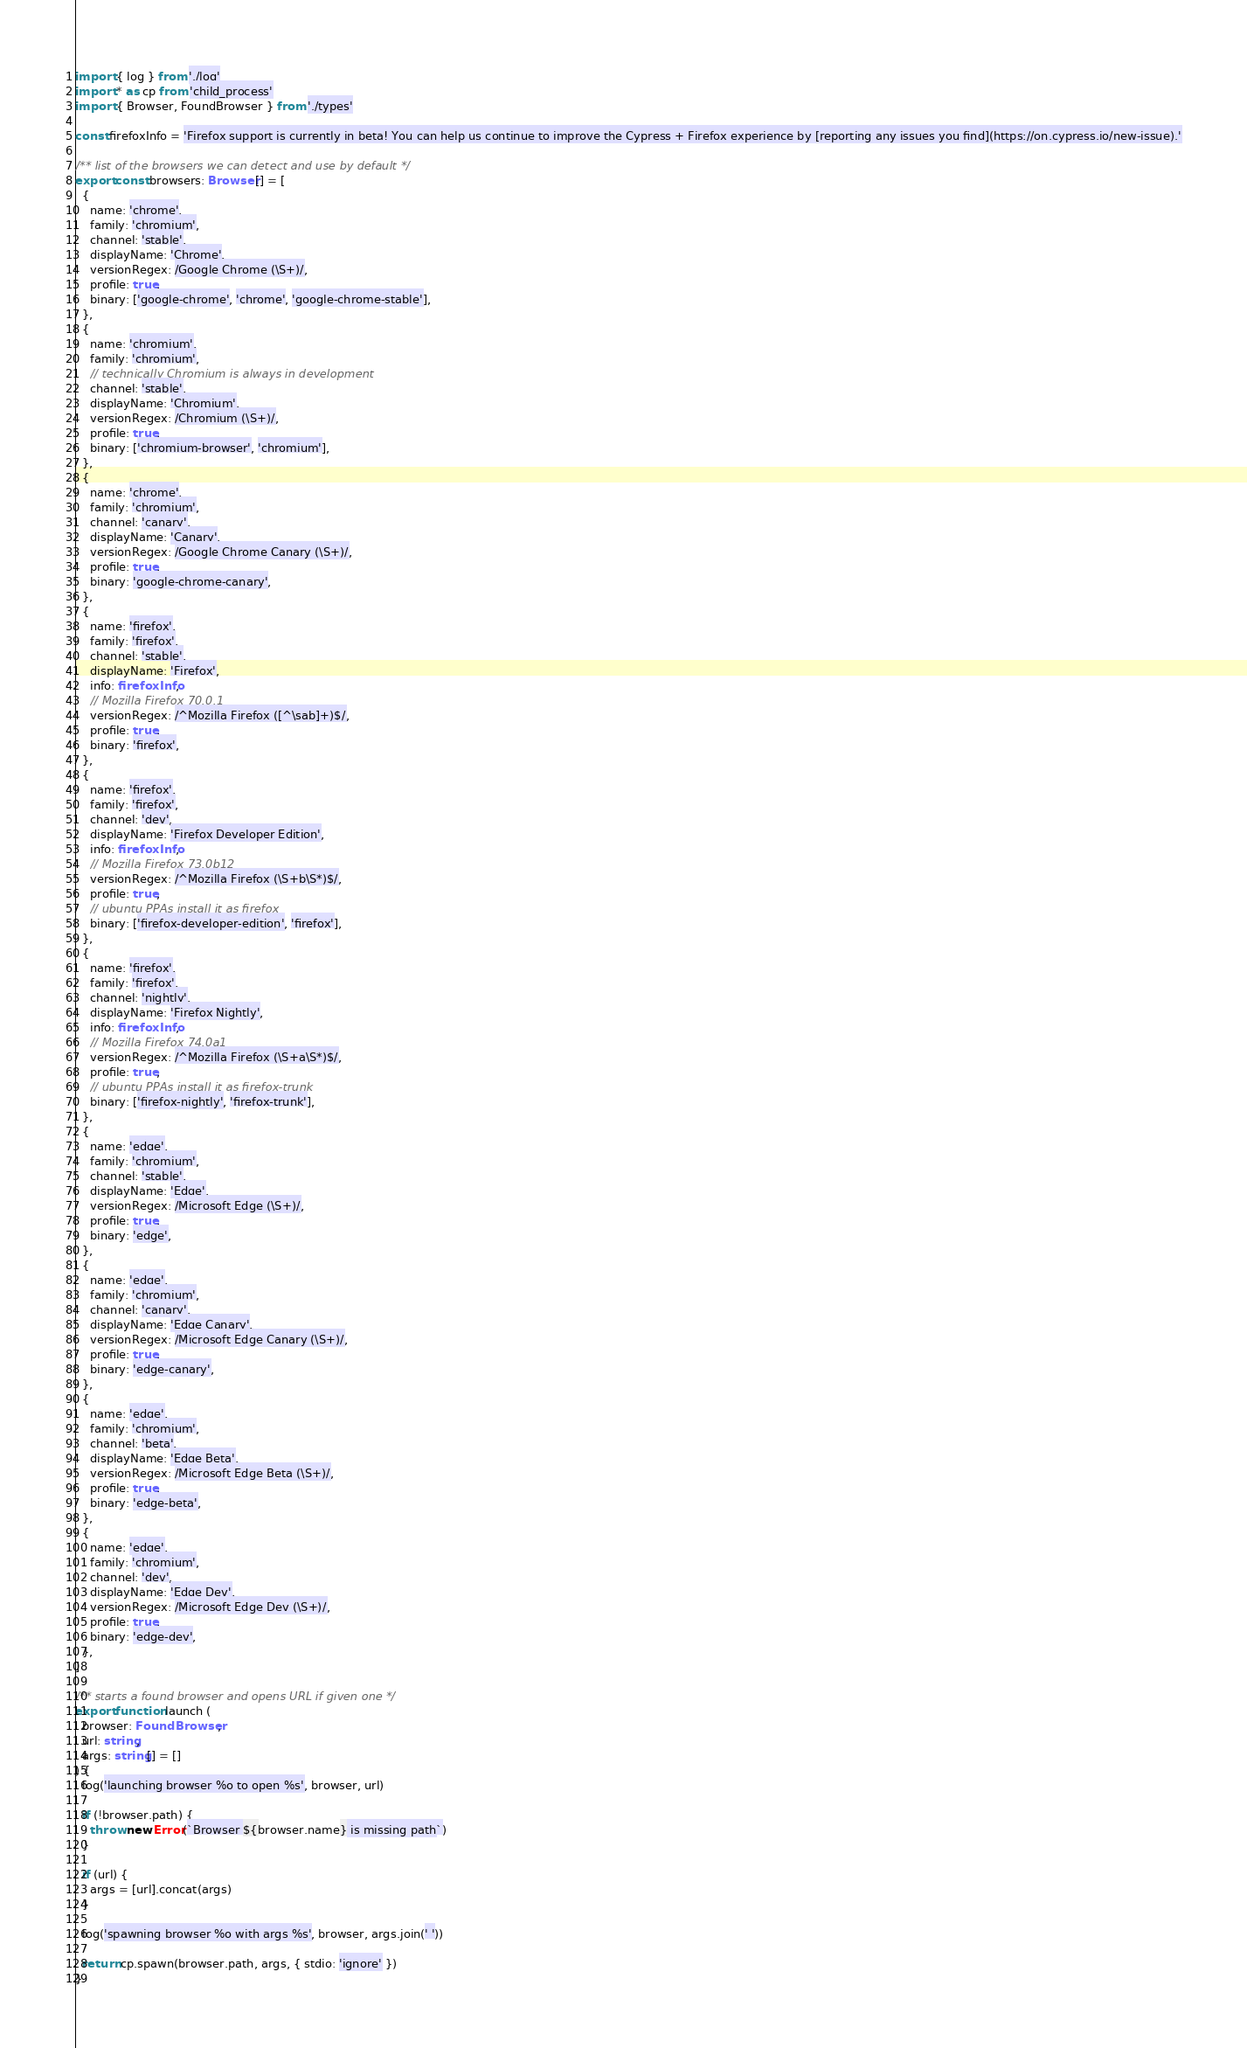Convert code to text. <code><loc_0><loc_0><loc_500><loc_500><_TypeScript_>import { log } from './log'
import * as cp from 'child_process'
import { Browser, FoundBrowser } from './types'

const firefoxInfo = 'Firefox support is currently in beta! You can help us continue to improve the Cypress + Firefox experience by [reporting any issues you find](https://on.cypress.io/new-issue).'

/** list of the browsers we can detect and use by default */
export const browsers: Browser[] = [
  {
    name: 'chrome',
    family: 'chromium',
    channel: 'stable',
    displayName: 'Chrome',
    versionRegex: /Google Chrome (\S+)/,
    profile: true,
    binary: ['google-chrome', 'chrome', 'google-chrome-stable'],
  },
  {
    name: 'chromium',
    family: 'chromium',
    // technically Chromium is always in development
    channel: 'stable',
    displayName: 'Chromium',
    versionRegex: /Chromium (\S+)/,
    profile: true,
    binary: ['chromium-browser', 'chromium'],
  },
  {
    name: 'chrome',
    family: 'chromium',
    channel: 'canary',
    displayName: 'Canary',
    versionRegex: /Google Chrome Canary (\S+)/,
    profile: true,
    binary: 'google-chrome-canary',
  },
  {
    name: 'firefox',
    family: 'firefox',
    channel: 'stable',
    displayName: 'Firefox',
    info: firefoxInfo,
    // Mozilla Firefox 70.0.1
    versionRegex: /^Mozilla Firefox ([^\sab]+)$/,
    profile: true,
    binary: 'firefox',
  },
  {
    name: 'firefox',
    family: 'firefox',
    channel: 'dev',
    displayName: 'Firefox Developer Edition',
    info: firefoxInfo,
    // Mozilla Firefox 73.0b12
    versionRegex: /^Mozilla Firefox (\S+b\S*)$/,
    profile: true,
    // ubuntu PPAs install it as firefox
    binary: ['firefox-developer-edition', 'firefox'],
  },
  {
    name: 'firefox',
    family: 'firefox',
    channel: 'nightly',
    displayName: 'Firefox Nightly',
    info: firefoxInfo,
    // Mozilla Firefox 74.0a1
    versionRegex: /^Mozilla Firefox (\S+a\S*)$/,
    profile: true,
    // ubuntu PPAs install it as firefox-trunk
    binary: ['firefox-nightly', 'firefox-trunk'],
  },
  {
    name: 'edge',
    family: 'chromium',
    channel: 'stable',
    displayName: 'Edge',
    versionRegex: /Microsoft Edge (\S+)/,
    profile: true,
    binary: 'edge',
  },
  {
    name: 'edge',
    family: 'chromium',
    channel: 'canary',
    displayName: 'Edge Canary',
    versionRegex: /Microsoft Edge Canary (\S+)/,
    profile: true,
    binary: 'edge-canary',
  },
  {
    name: 'edge',
    family: 'chromium',
    channel: 'beta',
    displayName: 'Edge Beta',
    versionRegex: /Microsoft Edge Beta (\S+)/,
    profile: true,
    binary: 'edge-beta',
  },
  {
    name: 'edge',
    family: 'chromium',
    channel: 'dev',
    displayName: 'Edge Dev',
    versionRegex: /Microsoft Edge Dev (\S+)/,
    profile: true,
    binary: 'edge-dev',
  },
]

/** starts a found browser and opens URL if given one */
export function launch (
  browser: FoundBrowser,
  url: string,
  args: string[] = []
) {
  log('launching browser %o to open %s', browser, url)

  if (!browser.path) {
    throw new Error(`Browser ${browser.name} is missing path`)
  }

  if (url) {
    args = [url].concat(args)
  }

  log('spawning browser %o with args %s', browser, args.join(' '))

  return cp.spawn(browser.path, args, { stdio: 'ignore' })
}
</code> 